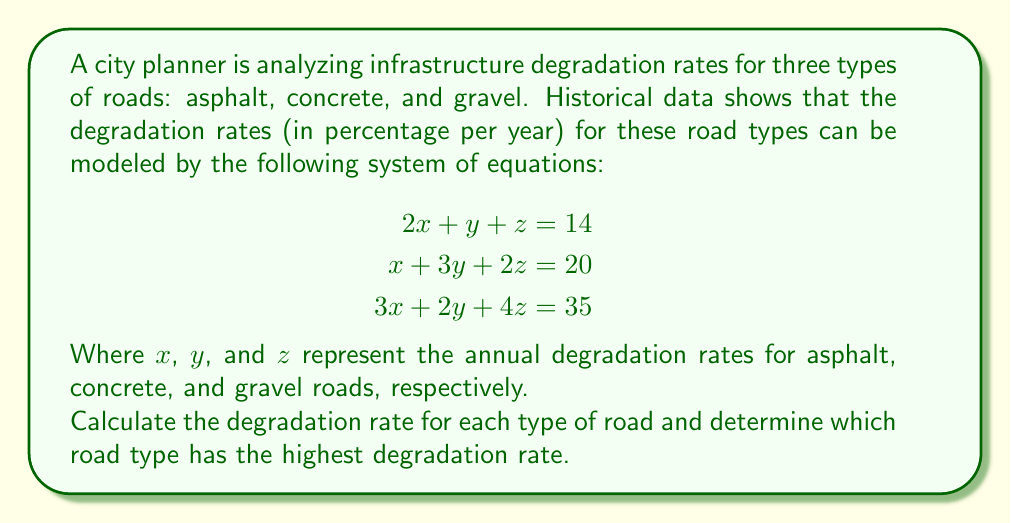Can you answer this question? To solve this system of equations, we'll use the elimination method:

1) Multiply the first equation by 3 and the second equation by -2:

   $$\begin{aligned}
   6x + 3y + 3z &= 42 \\
   -2x - 6y - 4z &= -40
   \end{aligned}$$

2) Add these equations to eliminate x:

   $$4y - z = 2 \quad \text{(Equation 4)}$$

3) Multiply the first equation by -3 and add it to the third equation:

   $$\begin{aligned}
   -6x - 3y - 3z &= -42 \\
   3x + 2y + 4z &= 35
   \end{aligned}$$

   $$-y + z = -7 \quad \text{(Equation 5)}$$

4) Multiply Equation 4 by -1 and add it to Equation 5:

   $$\begin{aligned}
   -4y + z &= -2 \\
   -y + z &= -7
   \end{aligned}$$

   $$-3y = -5$$
   $$y = \frac{5}{3}$$

5) Substitute y into Equation 5:

   $$-\frac{5}{3} + z = -7$$
   $$z = -7 + \frac{5}{3} = -\frac{16}{3}$$

6) Substitute y and z into the first original equation:

   $$2x + \frac{5}{3} + (-\frac{16}{3}) = 14$$
   $$2x - \frac{11}{3} = 14$$
   $$2x = \frac{53}{3}$$
   $$x = \frac{53}{6}$$

Therefore:
$x = \frac{53}{6} \approx 8.83\%$ (asphalt)
$y = \frac{5}{3} \approx 1.67\%$ (concrete)
$z = -\frac{16}{3} \approx -5.33\%$ (gravel)

The highest degradation rate is for asphalt roads at approximately 8.83% per year.
Answer: Asphalt: 8.83% per year
Concrete: 1.67% per year
Gravel: -5.33% per year (improvement)
Asphalt has the highest degradation rate. 